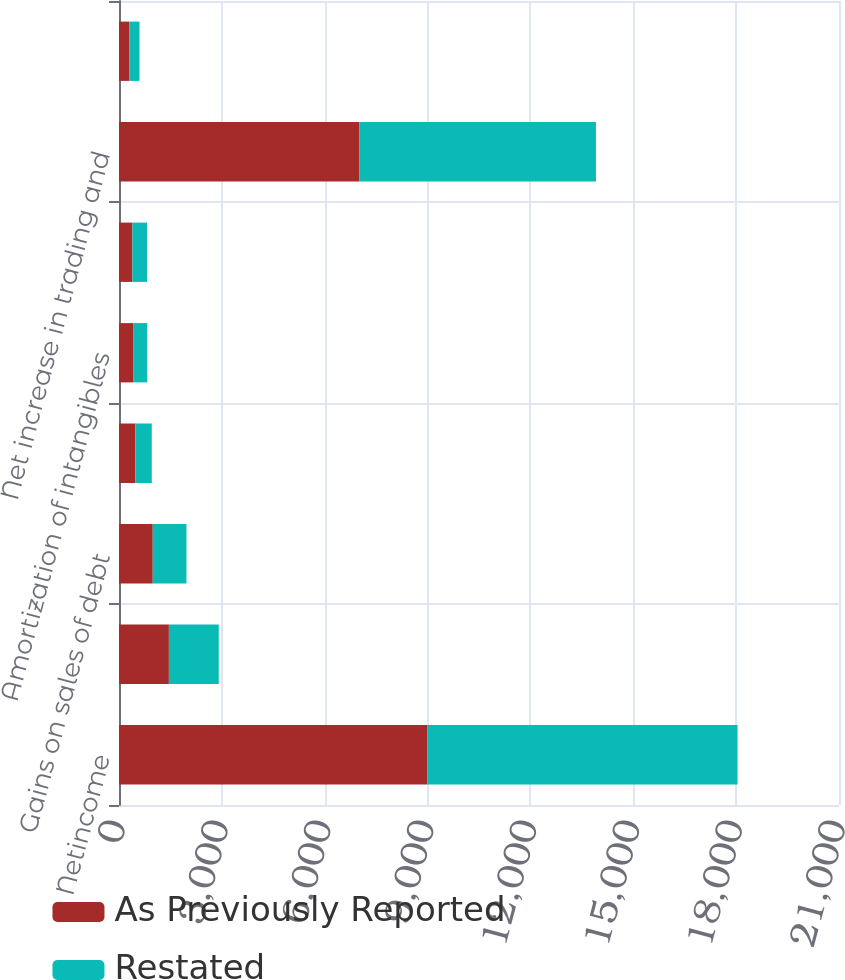Convert chart. <chart><loc_0><loc_0><loc_500><loc_500><stacked_bar_chart><ecel><fcel>Netincome<fcel>Provision for credit losses<fcel>Gains on sales of debt<fcel>Depreciation and premises<fcel>Amortization of intangibles<fcel>Deferred income tax expense<fcel>Net increase in trading and<fcel>Net increase in other assets<nl><fcel>As Previously Reported<fcel>8991<fcel>1455<fcel>984<fcel>478<fcel>412<fcel>391<fcel>7014<fcel>299<nl><fcel>Restated<fcel>9050<fcel>1455<fcel>984<fcel>478<fcel>412<fcel>425<fcel>6897<fcel>299<nl></chart> 